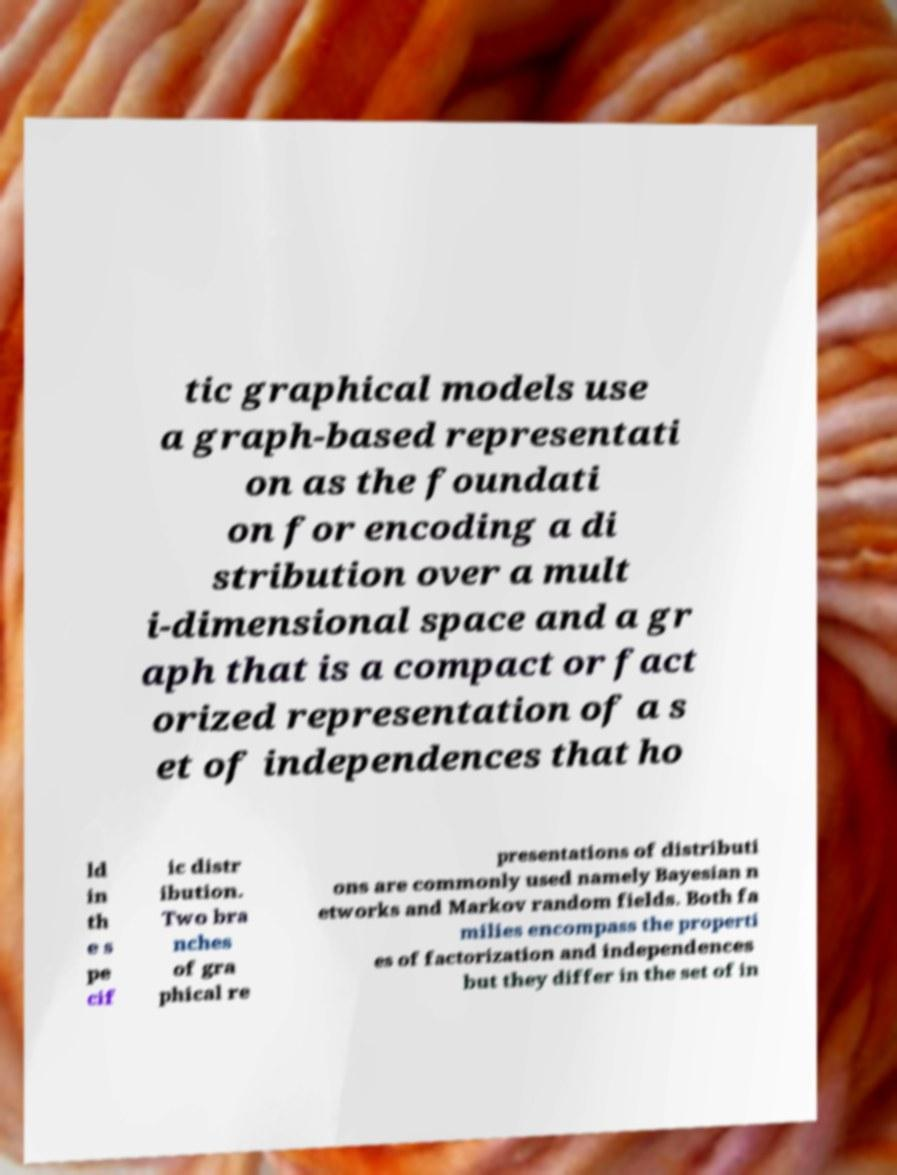Please read and relay the text visible in this image. What does it say? tic graphical models use a graph-based representati on as the foundati on for encoding a di stribution over a mult i-dimensional space and a gr aph that is a compact or fact orized representation of a s et of independences that ho ld in th e s pe cif ic distr ibution. Two bra nches of gra phical re presentations of distributi ons are commonly used namely Bayesian n etworks and Markov random fields. Both fa milies encompass the properti es of factorization and independences but they differ in the set of in 